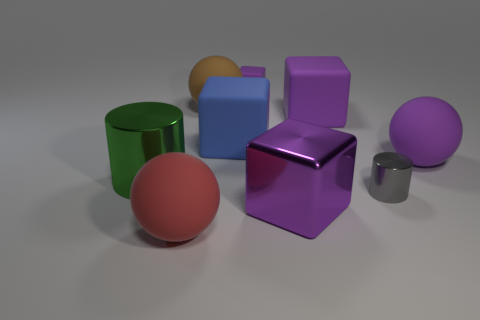Subtract all rubber blocks. How many blocks are left? 1 Subtract all blue blocks. How many blocks are left? 3 Subtract all yellow spheres. How many purple cubes are left? 3 Subtract all tiny cyan cubes. Subtract all big brown spheres. How many objects are left? 8 Add 5 big purple metal blocks. How many big purple metal blocks are left? 6 Add 6 large green metallic cylinders. How many large green metallic cylinders exist? 7 Subtract 0 gray spheres. How many objects are left? 9 Subtract all cylinders. How many objects are left? 7 Subtract all gray spheres. Subtract all brown cylinders. How many spheres are left? 3 